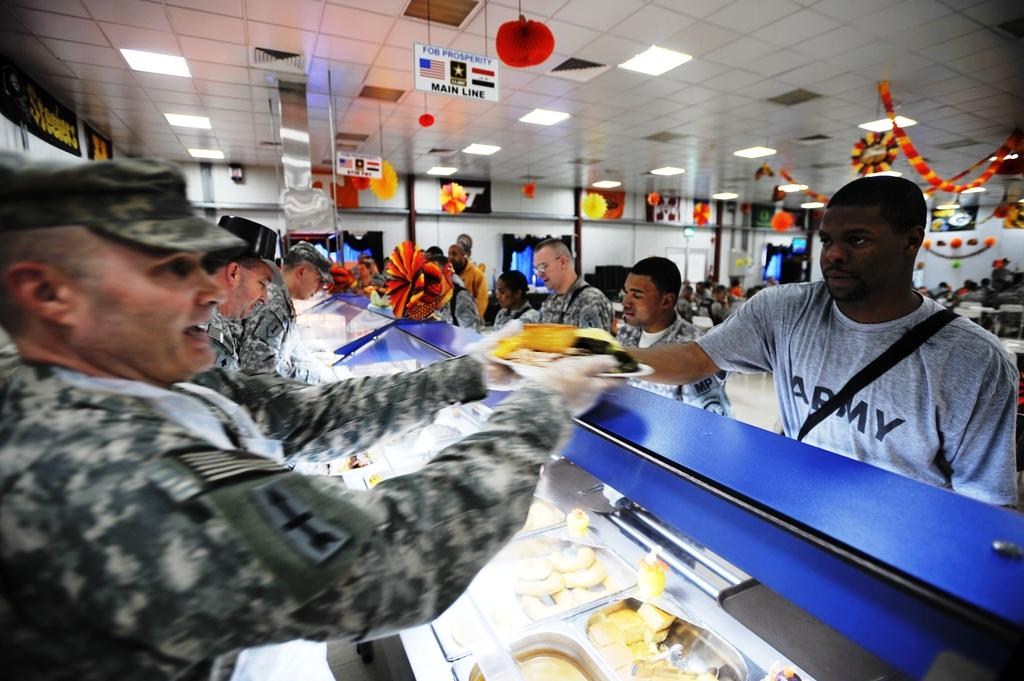What can be seen on the left side of the image? There are men standing on the left side of the image. What is located in the middle of the image? There are food items in the middle of the image. What is the position of the man on the right side of the image? There is a man standing on the right side of the image. What type of clothing is the man on the right side wearing? The man on the right side is wearing a t-shirt. What is visible at the top of the image? There are lights visible at the top of the image. Are the men on the left side of the image brothers? There is no information provided about the relationship between the men on the left side of the image, so we cannot determine if they are brothers. Does the existence of the food items in the image prove the existence of life on other planets? The presence of food items in the image does not provide any information about the existence of life on other planets. 